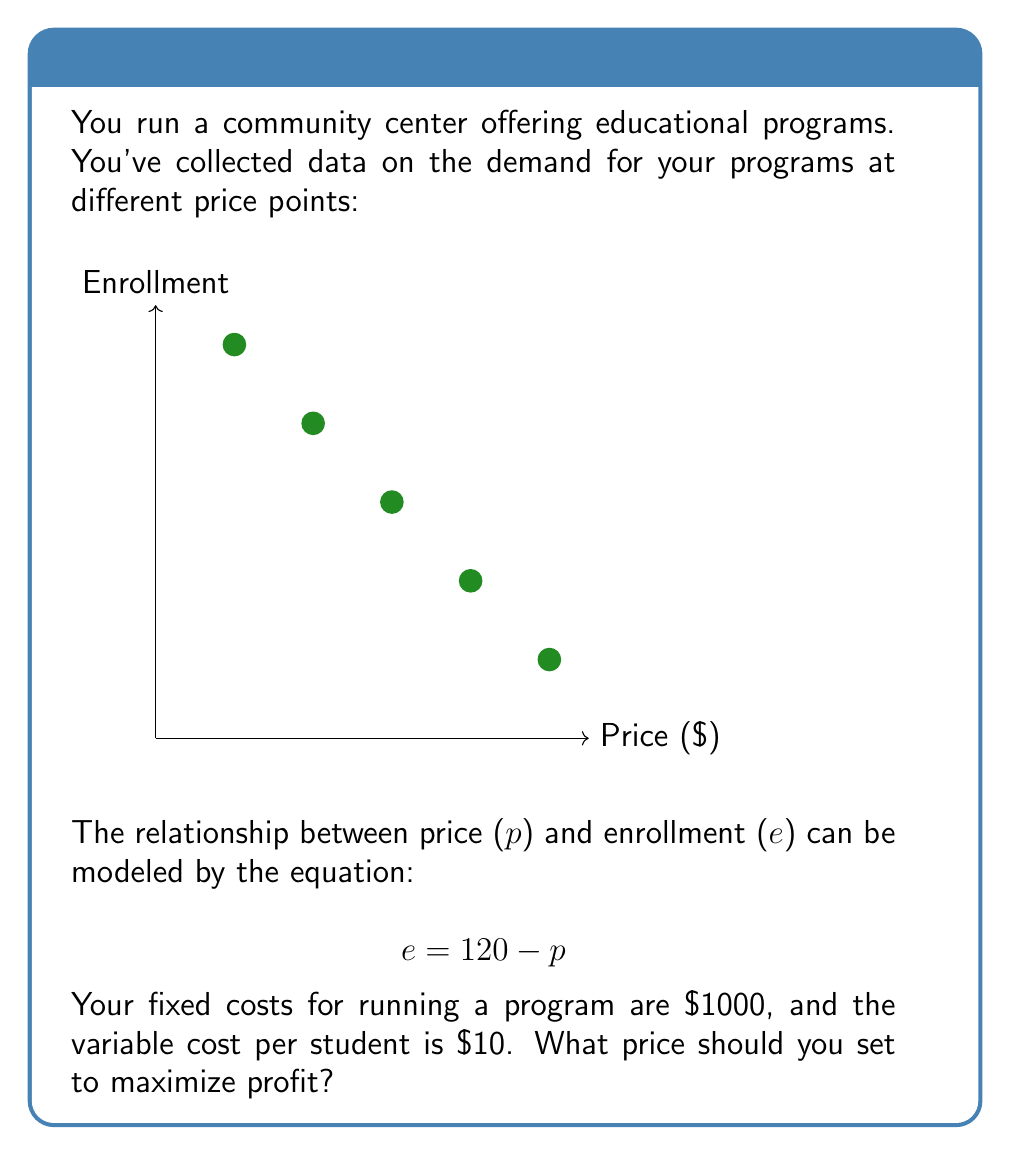What is the answer to this math problem? Let's approach this step-by-step:

1) First, let's define our profit function. Profit is revenue minus costs:

   $$ \text{Profit} = \text{Revenue} - \text{Costs} $$

2) Revenue is price times enrollment:

   $$ \text{Revenue} = p \cdot e = p \cdot (120 - p) = 120p - p^2 $$

3) Costs are fixed costs plus variable costs times enrollment:

   $$ \text{Costs} = 1000 + 10e = 1000 + 10(120 - p) = 2200 - 10p $$

4) Now we can write our profit function:

   $$ \text{Profit} = (120p - p^2) - (2200 - 10p) = 130p - p^2 - 2200 $$

5) To find the maximum profit, we need to find where the derivative of this function equals zero:

   $$ \frac{d}{dp}(\text{Profit}) = 130 - 2p $$

   $$ 130 - 2p = 0 $$
   $$ 2p = 130 $$
   $$ p = 65 $$

6) The second derivative is negative ($-2$), confirming this is a maximum, not a minimum.

7) Therefore, the profit-maximizing price is $\$65$.
Answer: $\$65$ 